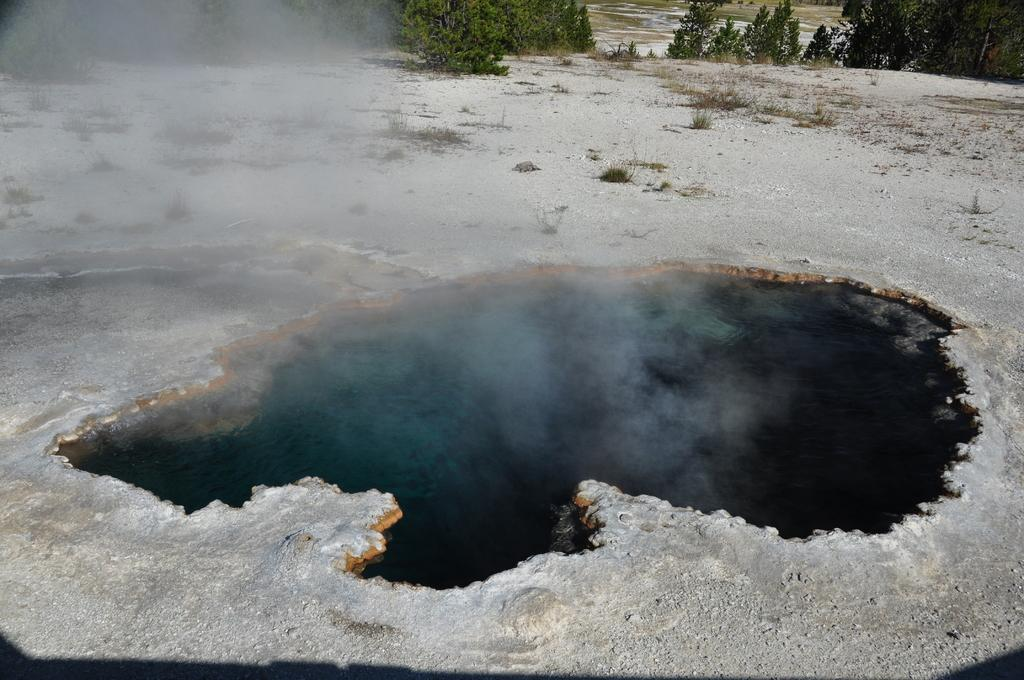What type of vegetation is present on the ground in the image? There are plants on the ground in the image. What natural element is visible in the image? Water is visible in the image. What is the atmospheric condition in the image? There is smoke in the image. What type of tall vegetation is present in the image? There are trees in the image. What type of vegetation can be seen in the background of the image? The background of the image includes grass. Can you tell me how many pins are holding up the beetle in the image? There is no beetle or pins present in the image. 